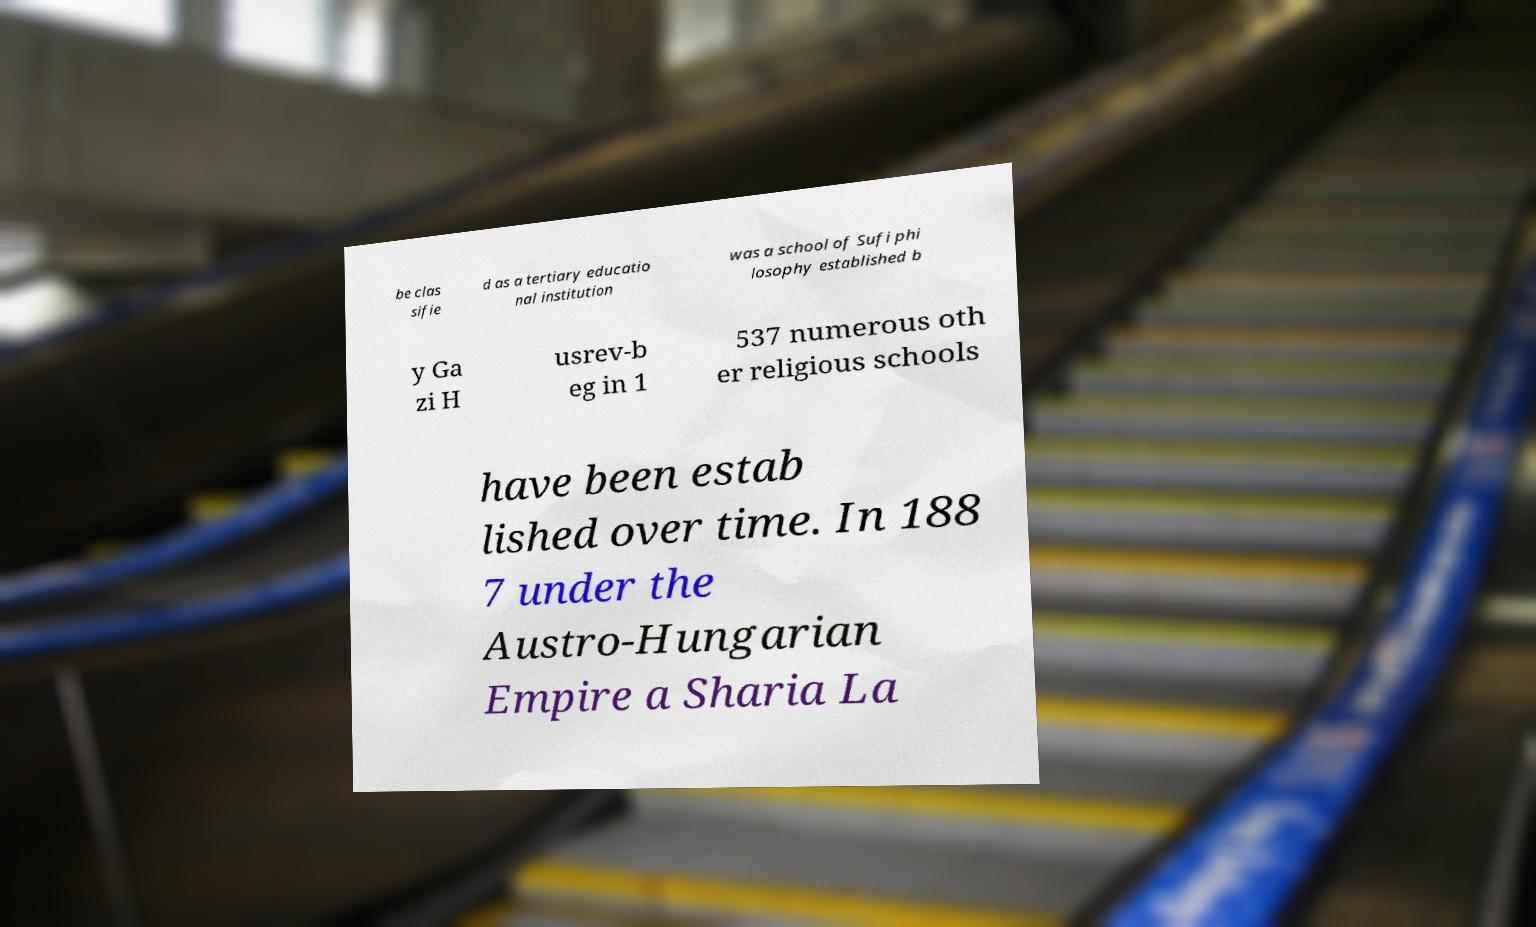I need the written content from this picture converted into text. Can you do that? be clas sifie d as a tertiary educatio nal institution was a school of Sufi phi losophy established b y Ga zi H usrev-b eg in 1 537 numerous oth er religious schools have been estab lished over time. In 188 7 under the Austro-Hungarian Empire a Sharia La 